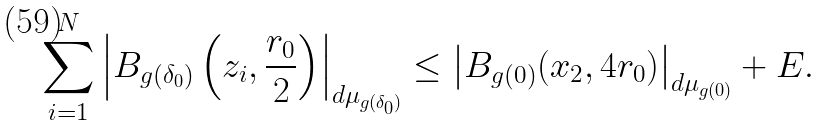<formula> <loc_0><loc_0><loc_500><loc_500>\sum _ { i = 1 } ^ { N } \left | B _ { g ( \delta _ { 0 } ) } \left ( z _ { i } , \frac { r _ { 0 } } { 2 } \right ) \right | _ { d \mu _ { g ( \delta _ { 0 } ) } } \leq \left | B _ { g ( 0 ) } ( x _ { 2 } , 4 r _ { 0 } ) \right | _ { d \mu _ { g ( 0 ) } } + E .</formula> 